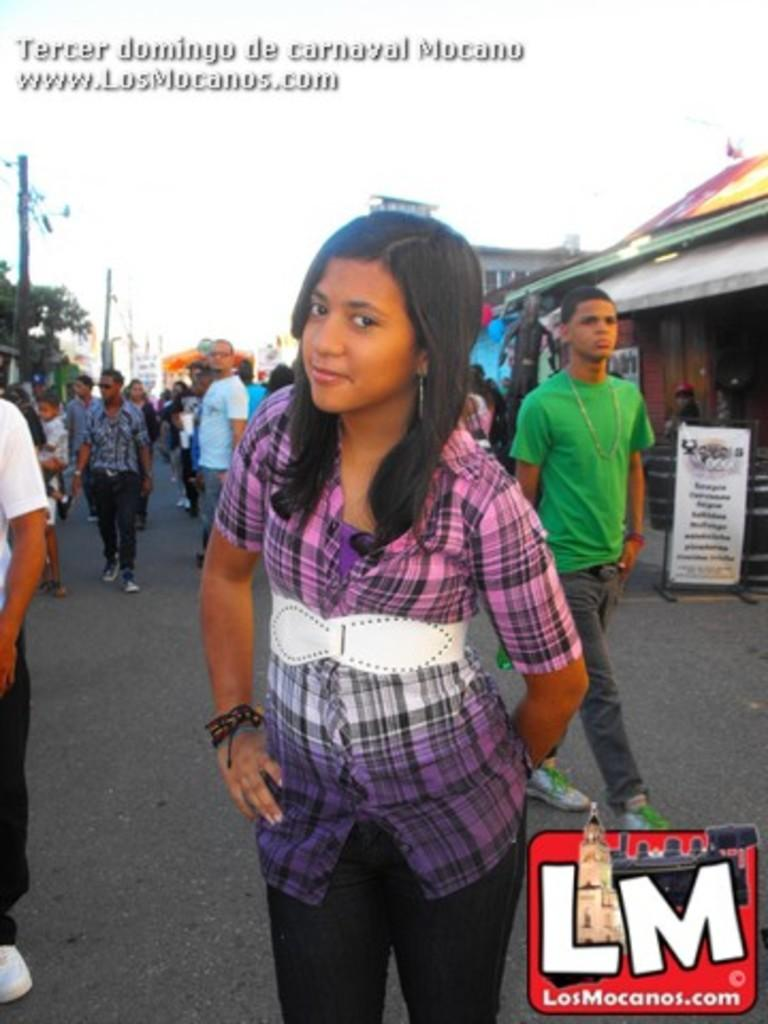What are the people in the image doing? The people in the image are standing on the road. What can be seen in the background of the image? In the background of the image, there are poles, trees, buildings, and the sky. Can you describe the poles in the background? The poles in the background are vertical structures that may be used for various purposes, such as supporting power lines or streetlights. What type of cake is being sorted by the people in the image? There is no cake present in the image; the people are standing on the road. 